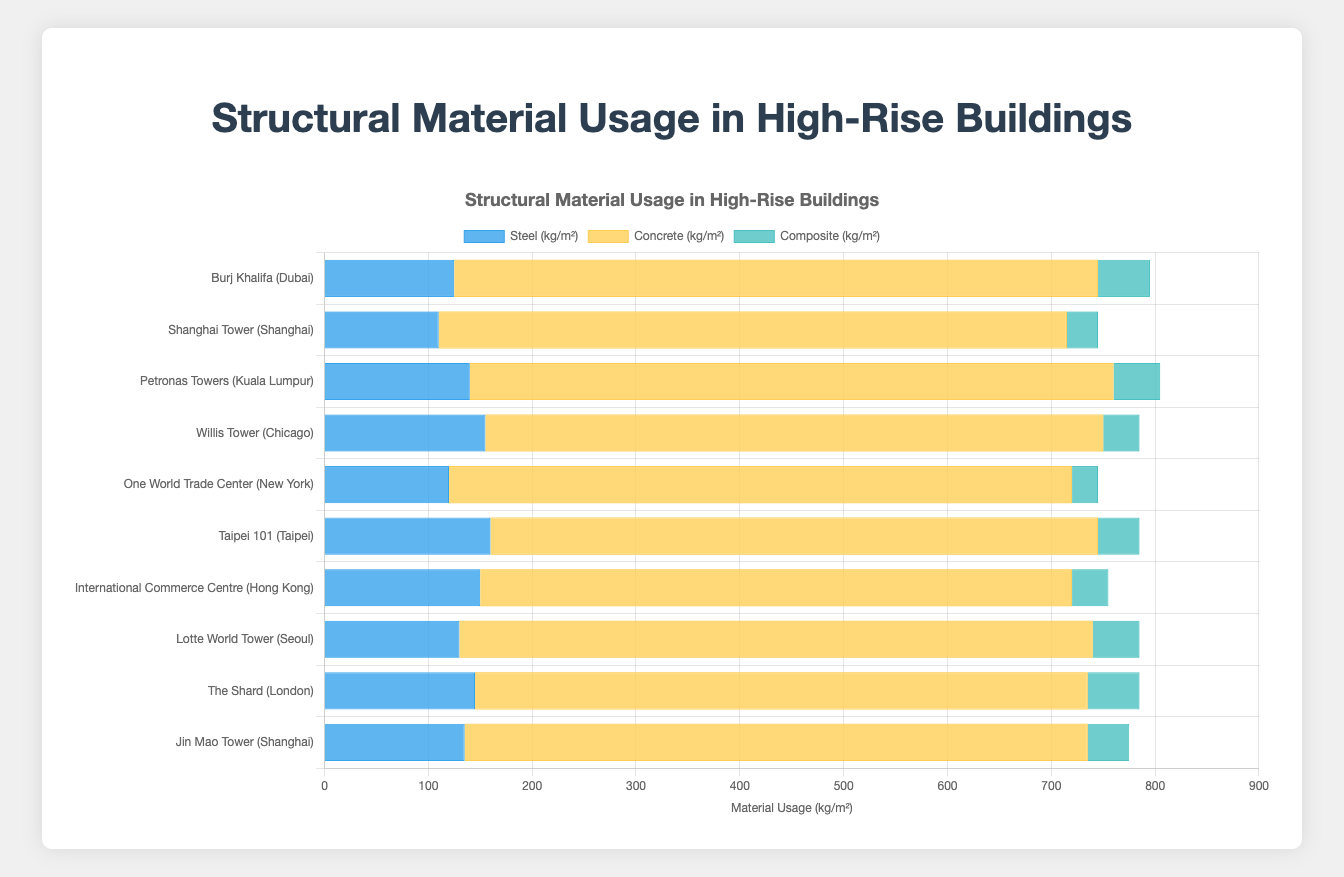What is the building with the highest usage of steel per square meter? Identify the building with the tallest blue bar, which represents steel usage. The Taipei 101 has the highest steel usage with a value of 160 kg/m².
Answer: Taipei 101 Which building uses the least amount of composite material? Look for the shortest green bar, representing composite material usage. The One World Trade Center uses the least composite material with 25 kg/m².
Answer: One World Trade Center How does the steel usage in the Jin Mao Tower compare to that in The Shard? Compare the heights of the blue bars for both buildings. The steel usage for Jin Mao Tower is 135 kg/m², whereas The Shard has 145 kg/m². Jin Mao Tower uses less steel than The Shard.
Answer: Jin Mao Tower uses less steel What is the total amount of concrete used per square meter in the Burj Khalifa and the Shanghai Tower combined? Sum the yellow bar values for both buildings. Burj Khalifa uses 620 kg/m² of concrete, and Shanghai Tower uses 605 kg/m². The total is 620 + 605 = 1225 kg/m².
Answer: 1225 kg/m² Which building has the tallest composite bar among the given high-rise buildings? Identify the tallest green bar. Both Burj Khalifa and The Shard have the tallest composite bars at 50 kg/m².
Answer: Burj Khalifa and The Shard Between the Willis Tower and International Commerce Centre, which building uses more concrete? Compare the heights of the yellow bars for both buildings. Willis Tower uses 595 kg/m², while International Commerce Centre uses 570 kg/m². Willis Tower uses more concrete.
Answer: Willis Tower What is the average steel usage across all the buildings? Sum the steel usages of all buildings and divide by the number of buildings. The sum is 125 + 110 + 140 + 155 + 120 + 160 + 150 + 130 + 145 + 135 = 1370 kg/m². There are 10 buildings, so the average is 1370 / 10 = 137 kg/m².
Answer: 137 kg/m² Between the Lotte World Tower and One World Trade Center, which has a higher overall material usage per square meter? Add the steel, concrete, and composite values for both buildings and compare. Lotte World Tower: 130 + 610 + 45 = 785 kg/m², One World Trade Center: 120 + 600 + 25 = 745 kg/m². Lotte World Tower has higher overall usage.
Answer: Lotte World Tower What is the most common range of concrete usage among these buildings? Observe the yellow bars and note the range where most values fall. Most buildings have concrete usage between 590-620 kg/m².
Answer: 590-620 kg/m² 